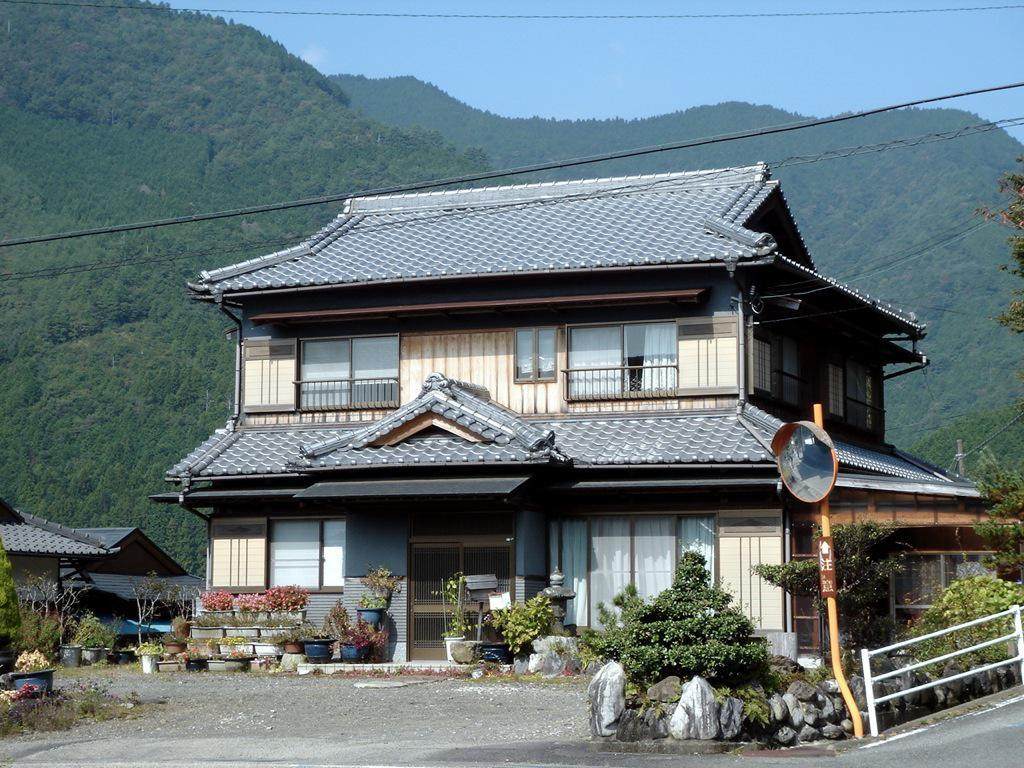What type of structures can be seen in the image? There are houses in the image. What is located in front of the houses? Plants, rocks, metal rods, and a convex mirror are located in front of the houses. What can be seen in the background of the image? Hills and trees are visible in the background of the image. What is the condition of the brother's car in the image? There is no brother or car present in the image. How hot is the weather in the image? The image does not provide any information about the weather or temperature. 